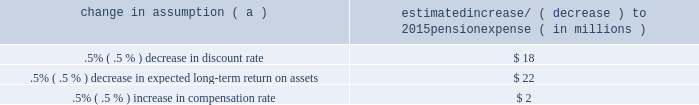The discount rate used to measure pension obligations is determined by comparing the expected future benefits that will be paid under the plan with yields available on high quality corporate bonds of similar duration .
The impact on pension expense of a .5% ( .5 % ) decrease in discount rate in the current environment is an increase of $ 18 million per year .
This sensitivity depends on the economic environment and amount of unrecognized actuarial gains or losses on the measurement date .
The expected long-term return on assets assumption also has a significant effect on pension expense .
The expected return on plan assets is a long-term assumption established by considering historical and anticipated returns of the asset classes invested in by the pension plan and the asset allocation policy currently in place .
For purposes of setting and reviewing this assumption , 201clong term 201d refers to the period over which the plan 2019s projected benefit obligations will be disbursed .
We review this assumption at each measurement date and adjust it if warranted .
Our selection process references certain historical data and the current environment , but primarily utilizes qualitative judgment regarding future return expectations .
To evaluate the continued reasonableness of our assumption , we examine a variety of viewpoints and data .
Various studies have shown that portfolios comprised primarily of u.s .
Equity securities have historically returned approximately 9% ( 9 % ) annually over long periods of time , while u.s .
Debt securities have returned approximately 6% ( 6 % ) annually over long periods .
Application of these historical returns to the plan 2019s allocation ranges for equities and bonds produces a result between 6.50% ( 6.50 % ) and 7.25% ( 7.25 % ) and is one point of reference , among many other factors , that is taken into consideration .
We also examine the plan 2019s actual historical returns over various periods and consider the current economic environment .
Recent experience is considered in our evaluation with appropriate consideration that , especially for short time periods , recent returns are not reliable indicators of future returns .
While annual returns can vary significantly ( actual returns for 2014 , 2013 and 2012 were +6.50% ( +6.50 % ) , +15.48% ( +15.48 % ) , and +15.29% ( +15.29 % ) , respectively ) , the selected assumption represents our estimated long-term average prospective returns .
Acknowledging the potentially wide range for this assumption , we also annually examine the assumption used by other companies with similar pension investment strategies , so that we can ascertain whether our determinations markedly differ from others .
In all cases , however , this data simply informs our process , which places the greatest emphasis on our qualitative judgment of future investment returns , given the conditions existing at each annual measurement date .
Taking into consideration all of these factors , the expected long-term return on plan assets for determining net periodic pension cost for 2014 was 7.00% ( 7.00 % ) , down from 7.50% ( 7.50 % ) for 2013 .
After considering the views of both internal and external capital market advisors , particularly with regard to the effects of the recent economic environment on long-term prospective fixed income returns , we are reducing our expected long-term return on assets to 6.75% ( 6.75 % ) for determining pension cost for under current accounting rules , the difference between expected long-term returns and actual returns is accumulated and amortized to pension expense over future periods .
Each one percentage point difference in actual return compared with our expected return can cause expense in subsequent years to increase or decrease by up to $ 9 million as the impact is amortized into results of operations .
We currently estimate pretax pension expense of $ 9 million in 2015 compared with pretax income of $ 7 million in 2014 .
This year-over-year expected increase in expense reflects the effects of the lower expected return on asset assumption , improved mortality , and the lower discount rate required to be used in 2015 .
These factors will be partially offset by the favorable impact of the increase in plan assets at december 31 , 2014 and the assumed return on a $ 200 million voluntary contribution to the plan made in february 2015 .
The table below reflects the estimated effects on pension expense of certain changes in annual assumptions , using 2015 estimated expense as a baseline .
Table 26 : pension expense 2013 sensitivity analysis change in assumption ( a ) estimated increase/ ( decrease ) to 2015 pension expense ( in millions ) .
( a ) the impact is the effect of changing the specified assumption while holding all other assumptions constant .
Our pension plan contribution requirements are not particularly sensitive to actuarial assumptions .
Investment performance has the most impact on contribution requirements and will drive the amount of required contributions in future years .
Also , current law , including the provisions of the pension protection act of 2006 , sets limits as to both minimum and maximum contributions to the plan .
Notwithstanding the voluntary contribution made in february 2015 noted above , we do not expect to be required to make any contributions to the plan during 2015 .
We maintain other defined benefit plans that have a less significant effect on financial results , including various nonqualified supplemental retirement plans for certain employees , which are described more fully in note 13 employee benefit plans in the notes to consolidated financial statements in item 8 of this report .
66 the pnc financial services group , inc .
2013 form 10-k .
For pension expense , does a .5% ( .5 % ) decrease in expected long-term return on assets have a greater impact than a .5% ( .5 % ) increase in compensation rate? 
Computations: (22 > 2)
Answer: yes. 